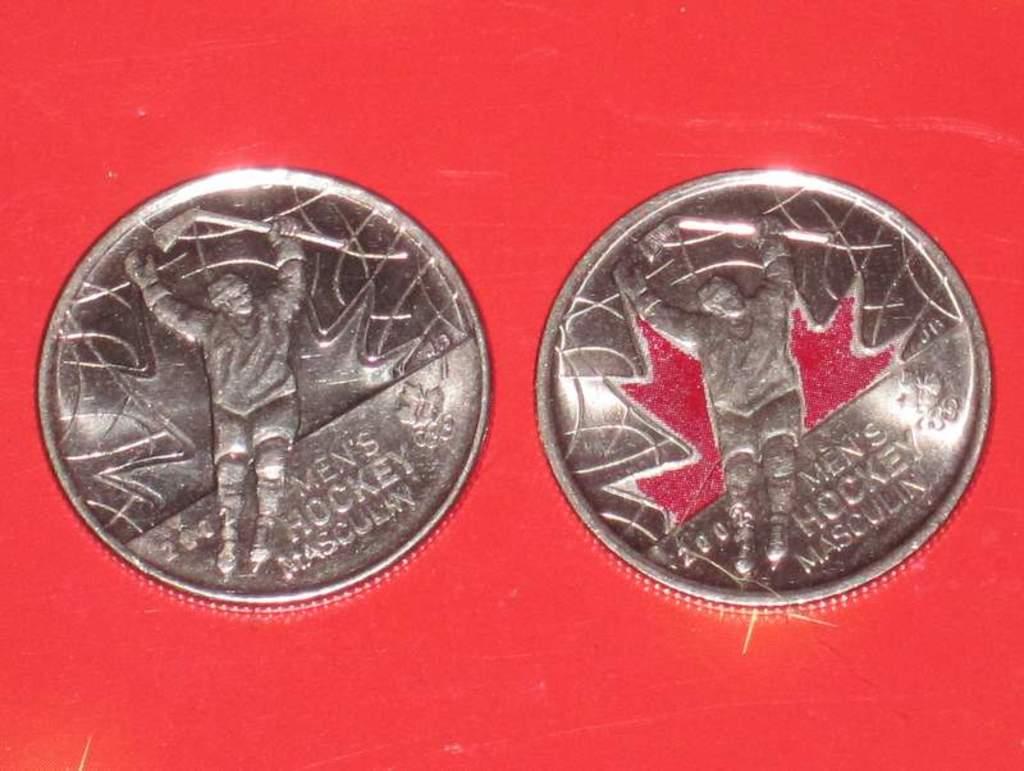What type of coins are these?
Offer a very short reply. Men's hockey. Does the coin have men's hockey engraved on it?
Make the answer very short. Yes. 